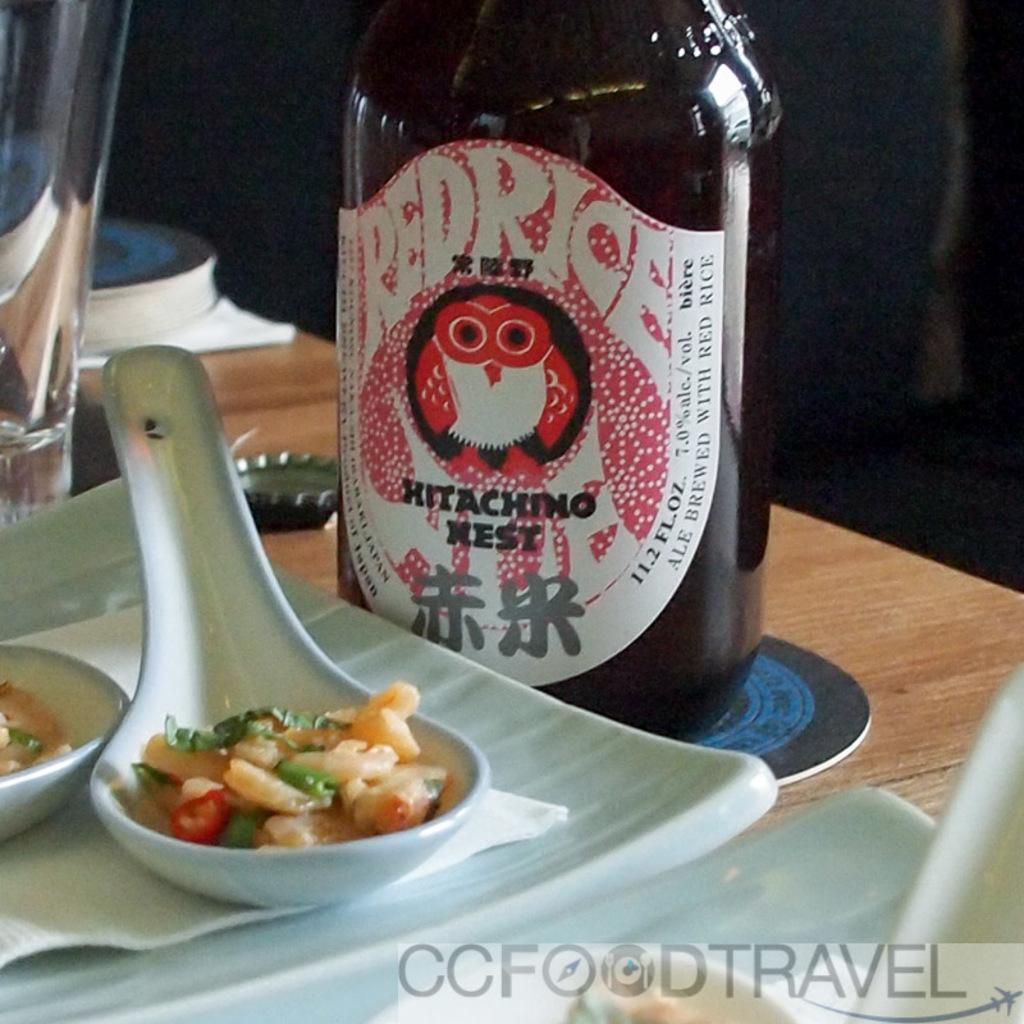<image>
Render a clear and concise summary of the photo. A bottle of Hitaching Nest sitting on a table 